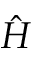Convert formula to latex. <formula><loc_0><loc_0><loc_500><loc_500>\hat { H }</formula> 